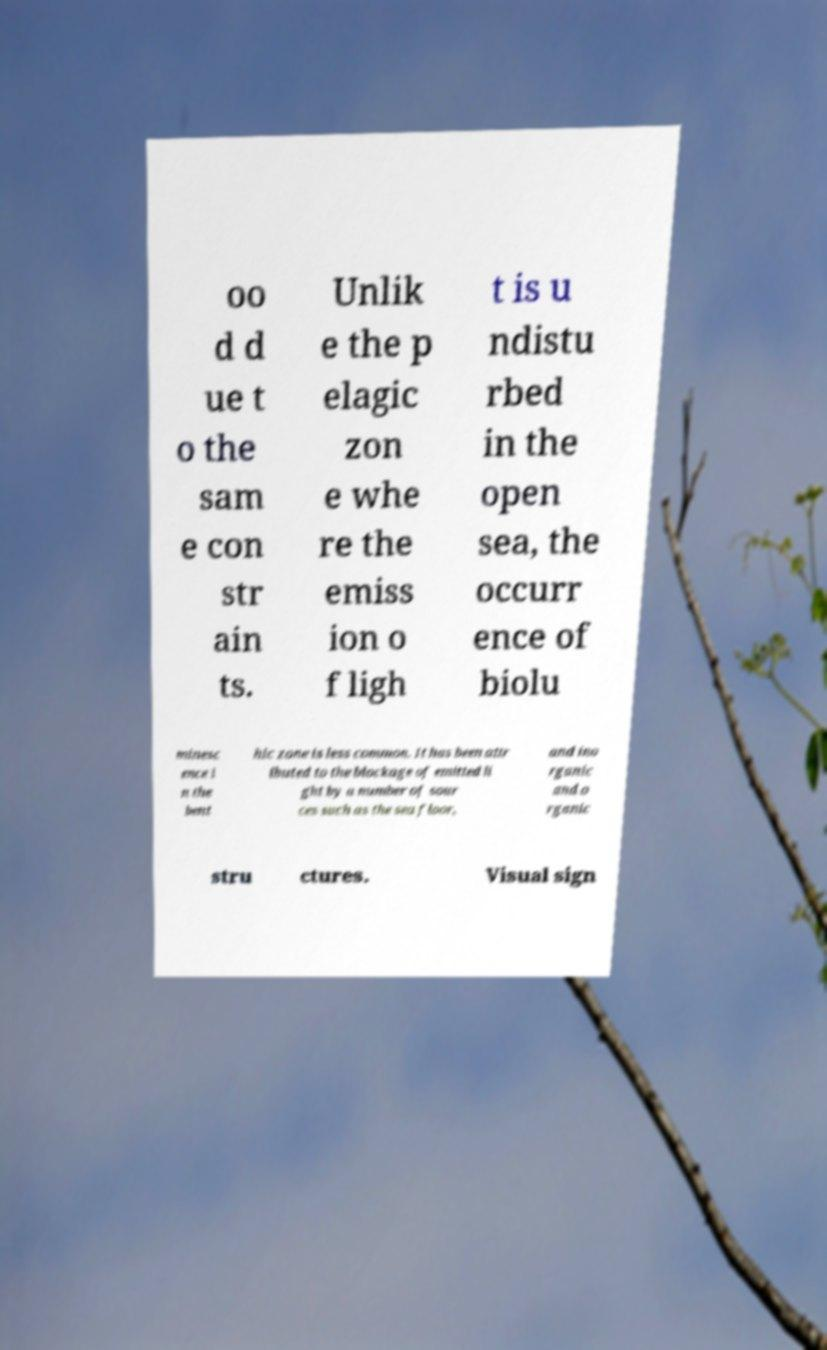There's text embedded in this image that I need extracted. Can you transcribe it verbatim? oo d d ue t o the sam e con str ain ts. Unlik e the p elagic zon e whe re the emiss ion o f ligh t is u ndistu rbed in the open sea, the occurr ence of biolu minesc ence i n the bent hic zone is less common. It has been attr ibuted to the blockage of emitted li ght by a number of sour ces such as the sea floor, and ino rganic and o rganic stru ctures. Visual sign 